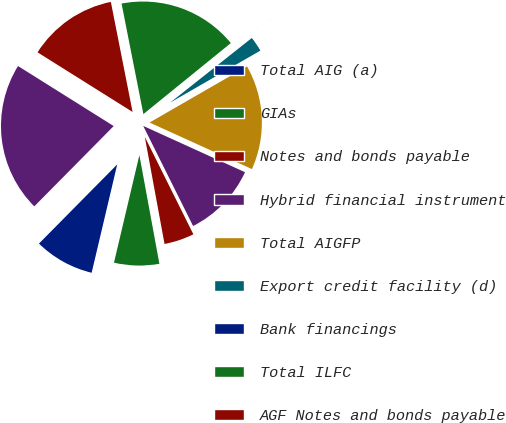Convert chart. <chart><loc_0><loc_0><loc_500><loc_500><pie_chart><fcel>Total AIG (a)<fcel>GIAs<fcel>Notes and bonds payable<fcel>Hybrid financial instrument<fcel>Total AIGFP<fcel>Export credit facility (d)<fcel>Bank financings<fcel>Total ILFC<fcel>AGF Notes and bonds payable<fcel>Total<nl><fcel>8.72%<fcel>6.59%<fcel>4.46%<fcel>10.85%<fcel>15.12%<fcel>2.33%<fcel>0.2%<fcel>17.25%<fcel>12.98%<fcel>21.51%<nl></chart> 